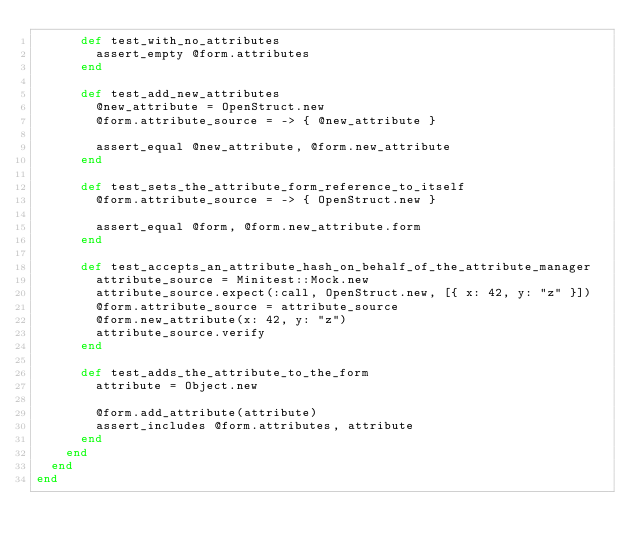Convert code to text. <code><loc_0><loc_0><loc_500><loc_500><_Ruby_>      def test_with_no_attributes
        assert_empty @form.attributes
      end

      def test_add_new_attributes
        @new_attribute = OpenStruct.new
        @form.attribute_source = -> { @new_attribute }

        assert_equal @new_attribute, @form.new_attribute
      end

      def test_sets_the_attribute_form_reference_to_itself
        @form.attribute_source = -> { OpenStruct.new }

        assert_equal @form, @form.new_attribute.form
      end

      def test_accepts_an_attribute_hash_on_behalf_of_the_attribute_manager
        attribute_source = Minitest::Mock.new
        attribute_source.expect(:call, OpenStruct.new, [{ x: 42, y: "z" }])
        @form.attribute_source = attribute_source
        @form.new_attribute(x: 42, y: "z")
        attribute_source.verify
      end

      def test_adds_the_attribute_to_the_form
        attribute = Object.new

        @form.add_attribute(attribute)
        assert_includes @form.attributes, attribute
      end
    end
  end
end
</code> 